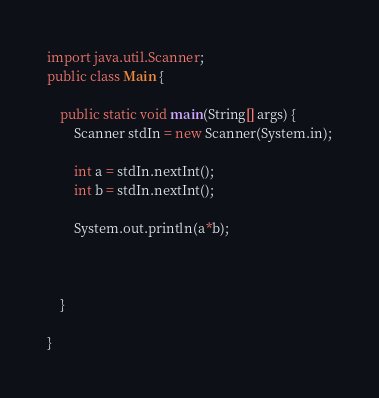Convert code to text. <code><loc_0><loc_0><loc_500><loc_500><_Java_>import java.util.Scanner;
public class Main {

	public static void main(String[] args) {
		Scanner stdIn = new Scanner(System.in);
		
		int a = stdIn.nextInt();
		int b = stdIn.nextInt();
		
		System.out.println(a*b);
		
		
		
	}

}
</code> 